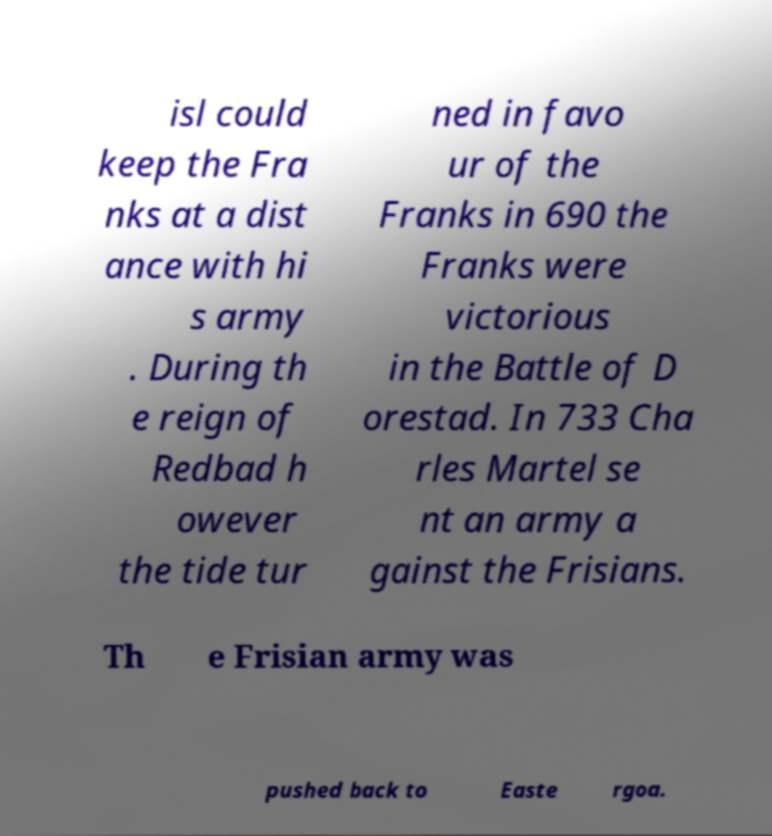Please read and relay the text visible in this image. What does it say? isl could keep the Fra nks at a dist ance with hi s army . During th e reign of Redbad h owever the tide tur ned in favo ur of the Franks in 690 the Franks were victorious in the Battle of D orestad. In 733 Cha rles Martel se nt an army a gainst the Frisians. Th e Frisian army was pushed back to Easte rgoa. 